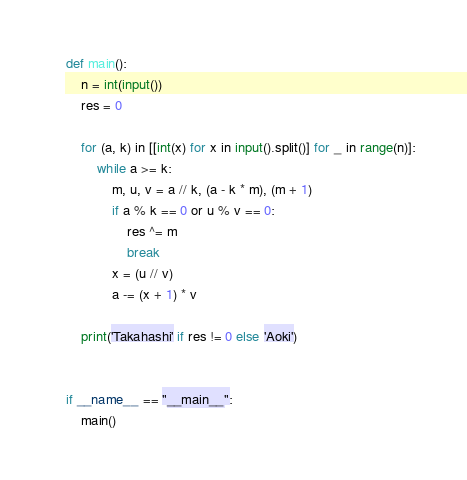<code> <loc_0><loc_0><loc_500><loc_500><_Python_>def main():
    n = int(input())
    res = 0

    for (a, k) in [[int(x) for x in input().split()] for _ in range(n)]:
        while a >= k:
            m, u, v = a // k, (a - k * m), (m + 1)
            if a % k == 0 or u % v == 0:
                res ^= m
                break
            x = (u // v)
            a -= (x + 1) * v

    print('Takahashi' if res != 0 else 'Aoki')


if __name__ == "__main__":
    main()
</code> 